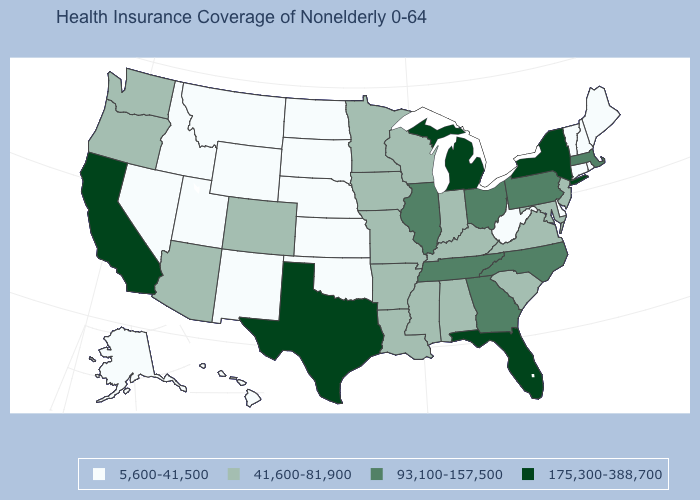Does the map have missing data?
Write a very short answer. No. What is the value of Maine?
Answer briefly. 5,600-41,500. What is the value of Georgia?
Be succinct. 93,100-157,500. Does the first symbol in the legend represent the smallest category?
Write a very short answer. Yes. Name the states that have a value in the range 175,300-388,700?
Answer briefly. California, Florida, Michigan, New York, Texas. Which states hav the highest value in the MidWest?
Quick response, please. Michigan. What is the value of Hawaii?
Give a very brief answer. 5,600-41,500. What is the value of Oklahoma?
Short answer required. 5,600-41,500. What is the highest value in states that border Kentucky?
Write a very short answer. 93,100-157,500. How many symbols are there in the legend?
Answer briefly. 4. What is the lowest value in the Northeast?
Keep it brief. 5,600-41,500. Among the states that border North Carolina , which have the lowest value?
Be succinct. South Carolina, Virginia. Name the states that have a value in the range 5,600-41,500?
Concise answer only. Alaska, Connecticut, Delaware, Hawaii, Idaho, Kansas, Maine, Montana, Nebraska, Nevada, New Hampshire, New Mexico, North Dakota, Oklahoma, Rhode Island, South Dakota, Utah, Vermont, West Virginia, Wyoming. What is the value of Utah?
Concise answer only. 5,600-41,500. 